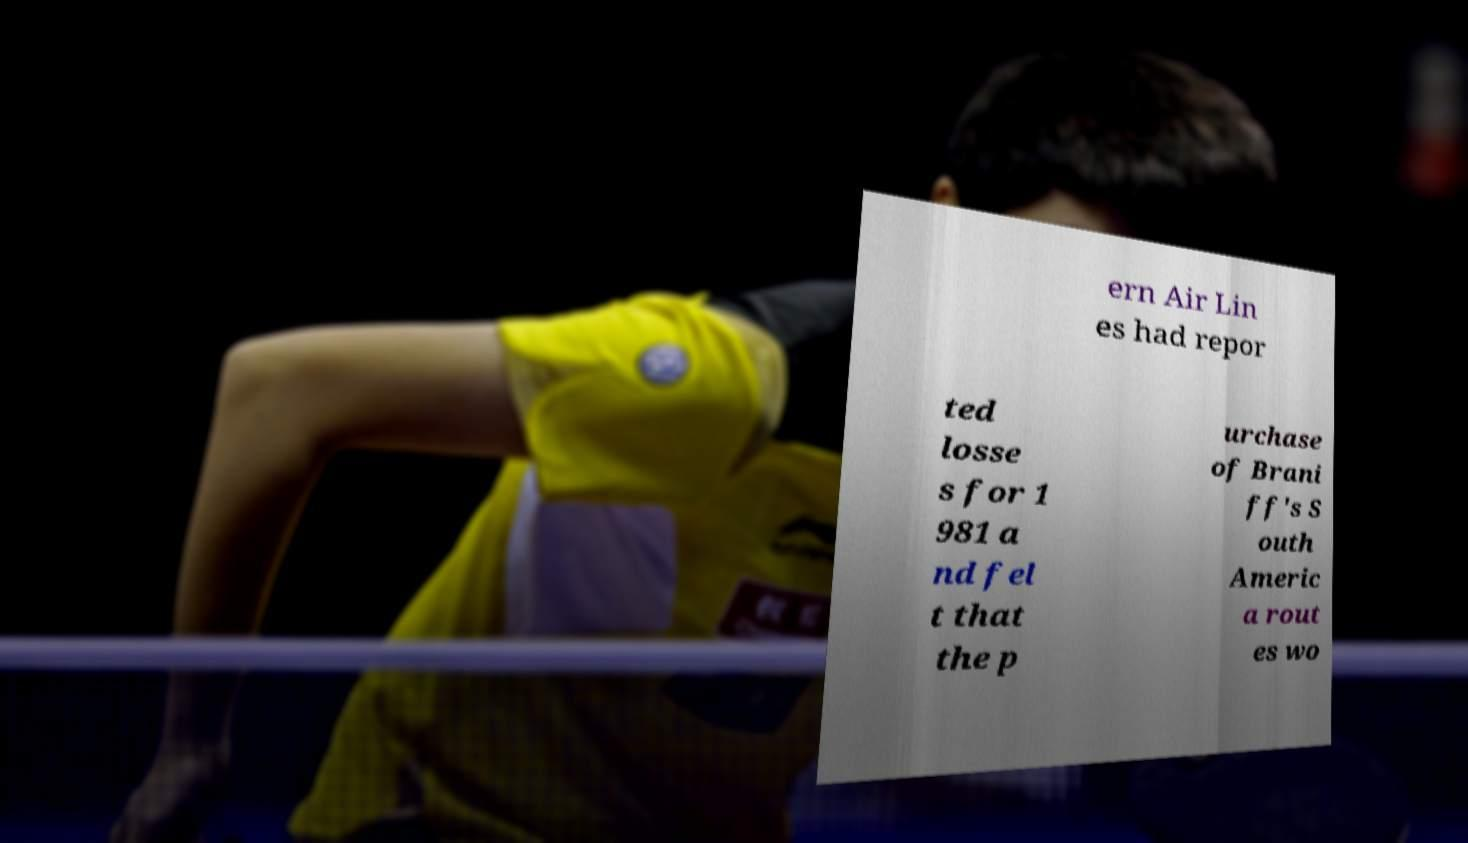Could you extract and type out the text from this image? ern Air Lin es had repor ted losse s for 1 981 a nd fel t that the p urchase of Brani ff's S outh Americ a rout es wo 